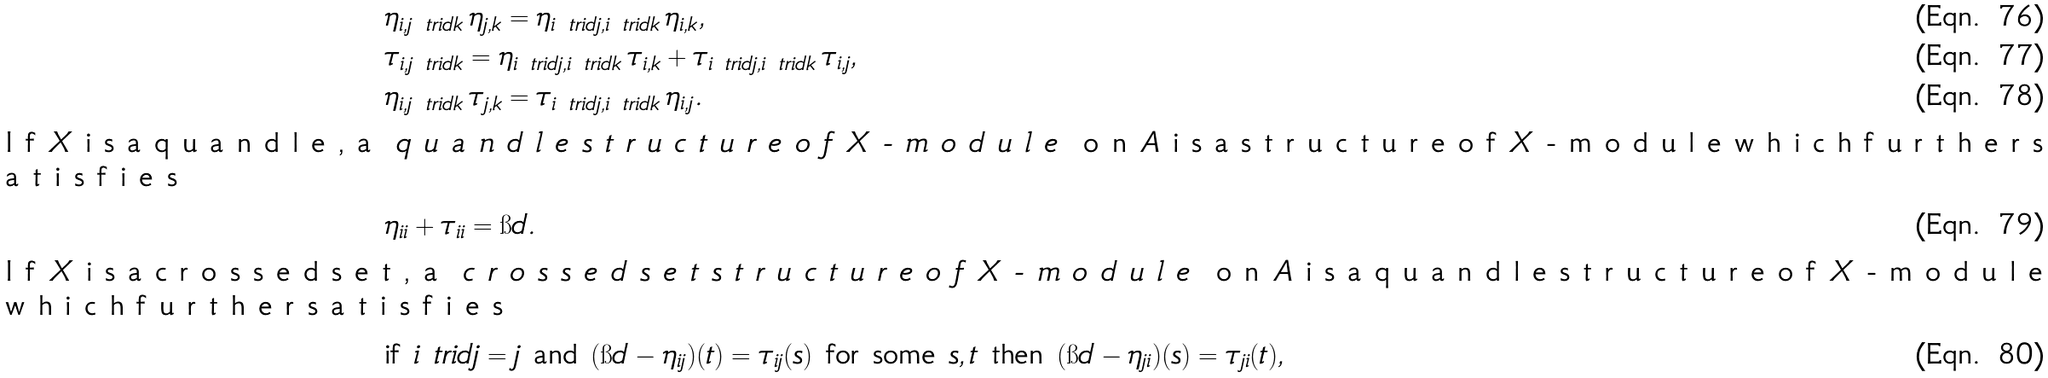Convert formula to latex. <formula><loc_0><loc_0><loc_500><loc_500>& \eta _ { i , j \ t r i d k } \, \eta _ { j , k } = \eta _ { i \ t r i d j , i \ t r i d k } \, \eta _ { i , k } , & \\ & \tau _ { i , j \ t r i d k } = \eta _ { i \ t r i d j , i \ t r i d k } \, \tau _ { i , k } + \tau _ { i \ t r i d j , i \ t r i d k } \, \tau _ { i , j } , & \\ & \eta _ { i , j \ t r i d k } \, \tau _ { j , k } = \tau _ { i \ t r i d j , i \ t r i d k } \, \eta _ { i , j } . & \\ \intertext { I f $ X $ i s a q u a n d l e , a \emph { q u a n d l e s t r u c t u r e o f $ X $ - m o d u l e } o n $ A $ i s a s t r u c t u r e o f $ X $ - m o d u l e w h i c h f u r t h e r s a t i s f i e s } & \eta _ { i i } + \tau _ { i i } = \i d . & \\ \intertext { I f $ X $ i s a c r o s s e d s e t , a \emph { c r o s s e d s e t s t r u c t u r e o f $ X $ - m o d u l e } o n $ A $ i s a q u a n d l e s t r u c t u r e o f $ X $ - m o d u l e w h i c h f u r t h e r s a t i s f i e s } & \text {if } i \ t r i d j = j \text { and } ( \i d - \eta _ { i j } ) ( t ) = \tau _ { i j } ( s ) \text { for some } s , t \text { then } ( \i d - \eta _ { j i } ) ( s ) = \tau _ { j i } ( t ) , &</formula> 